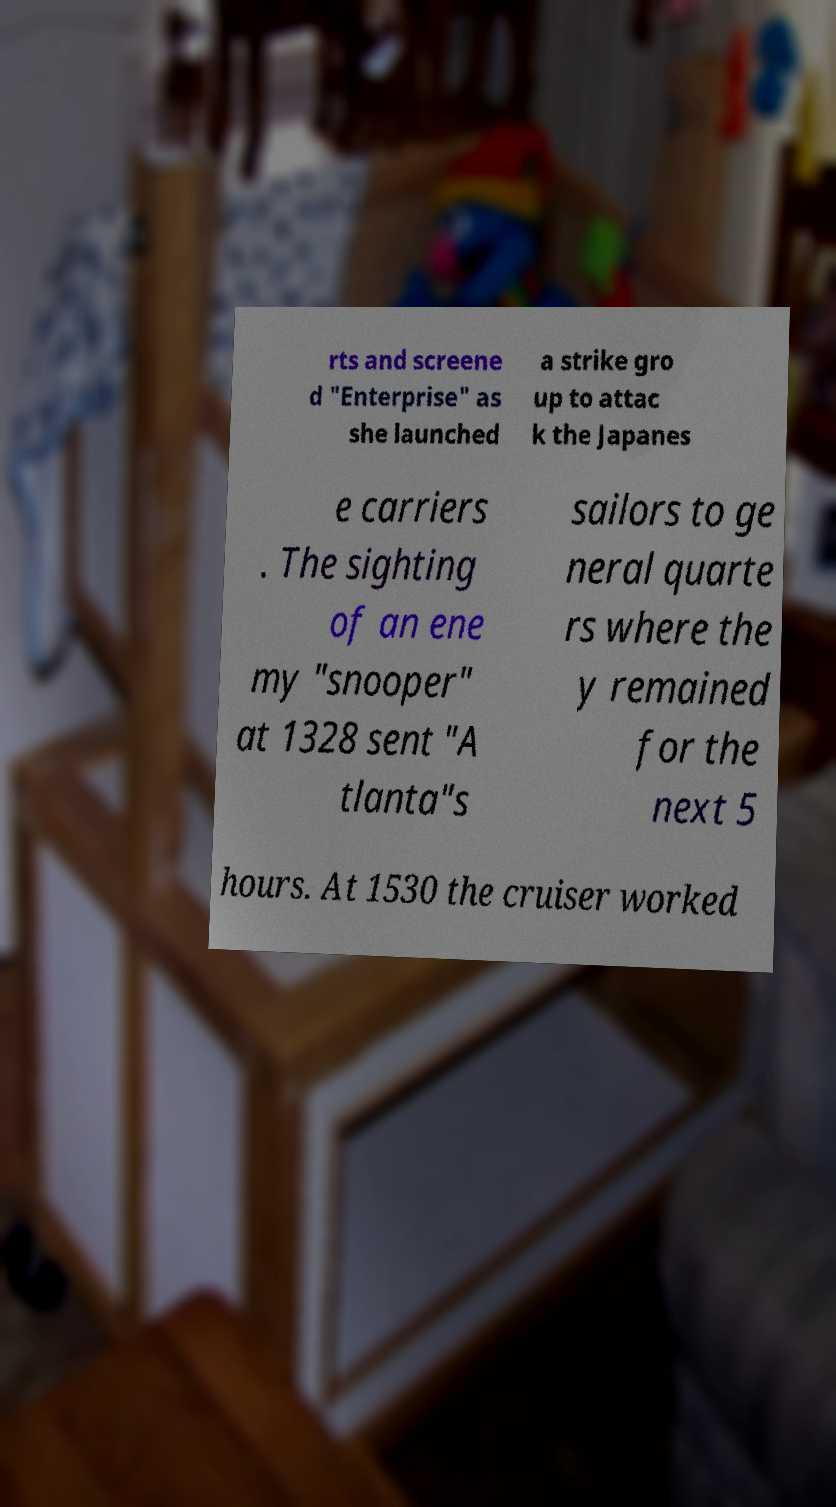I need the written content from this picture converted into text. Can you do that? rts and screene d "Enterprise" as she launched a strike gro up to attac k the Japanes e carriers . The sighting of an ene my "snooper" at 1328 sent "A tlanta"s sailors to ge neral quarte rs where the y remained for the next 5 hours. At 1530 the cruiser worked 